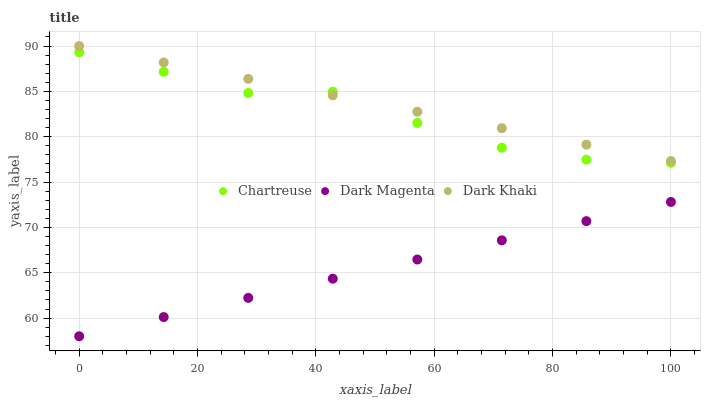Does Dark Magenta have the minimum area under the curve?
Answer yes or no. Yes. Does Dark Khaki have the maximum area under the curve?
Answer yes or no. Yes. Does Chartreuse have the minimum area under the curve?
Answer yes or no. No. Does Chartreuse have the maximum area under the curve?
Answer yes or no. No. Is Dark Khaki the smoothest?
Answer yes or no. Yes. Is Chartreuse the roughest?
Answer yes or no. Yes. Is Dark Magenta the smoothest?
Answer yes or no. No. Is Dark Magenta the roughest?
Answer yes or no. No. Does Dark Magenta have the lowest value?
Answer yes or no. Yes. Does Chartreuse have the lowest value?
Answer yes or no. No. Does Dark Khaki have the highest value?
Answer yes or no. Yes. Does Chartreuse have the highest value?
Answer yes or no. No. Is Dark Magenta less than Chartreuse?
Answer yes or no. Yes. Is Dark Khaki greater than Dark Magenta?
Answer yes or no. Yes. Does Chartreuse intersect Dark Khaki?
Answer yes or no. Yes. Is Chartreuse less than Dark Khaki?
Answer yes or no. No. Is Chartreuse greater than Dark Khaki?
Answer yes or no. No. Does Dark Magenta intersect Chartreuse?
Answer yes or no. No. 